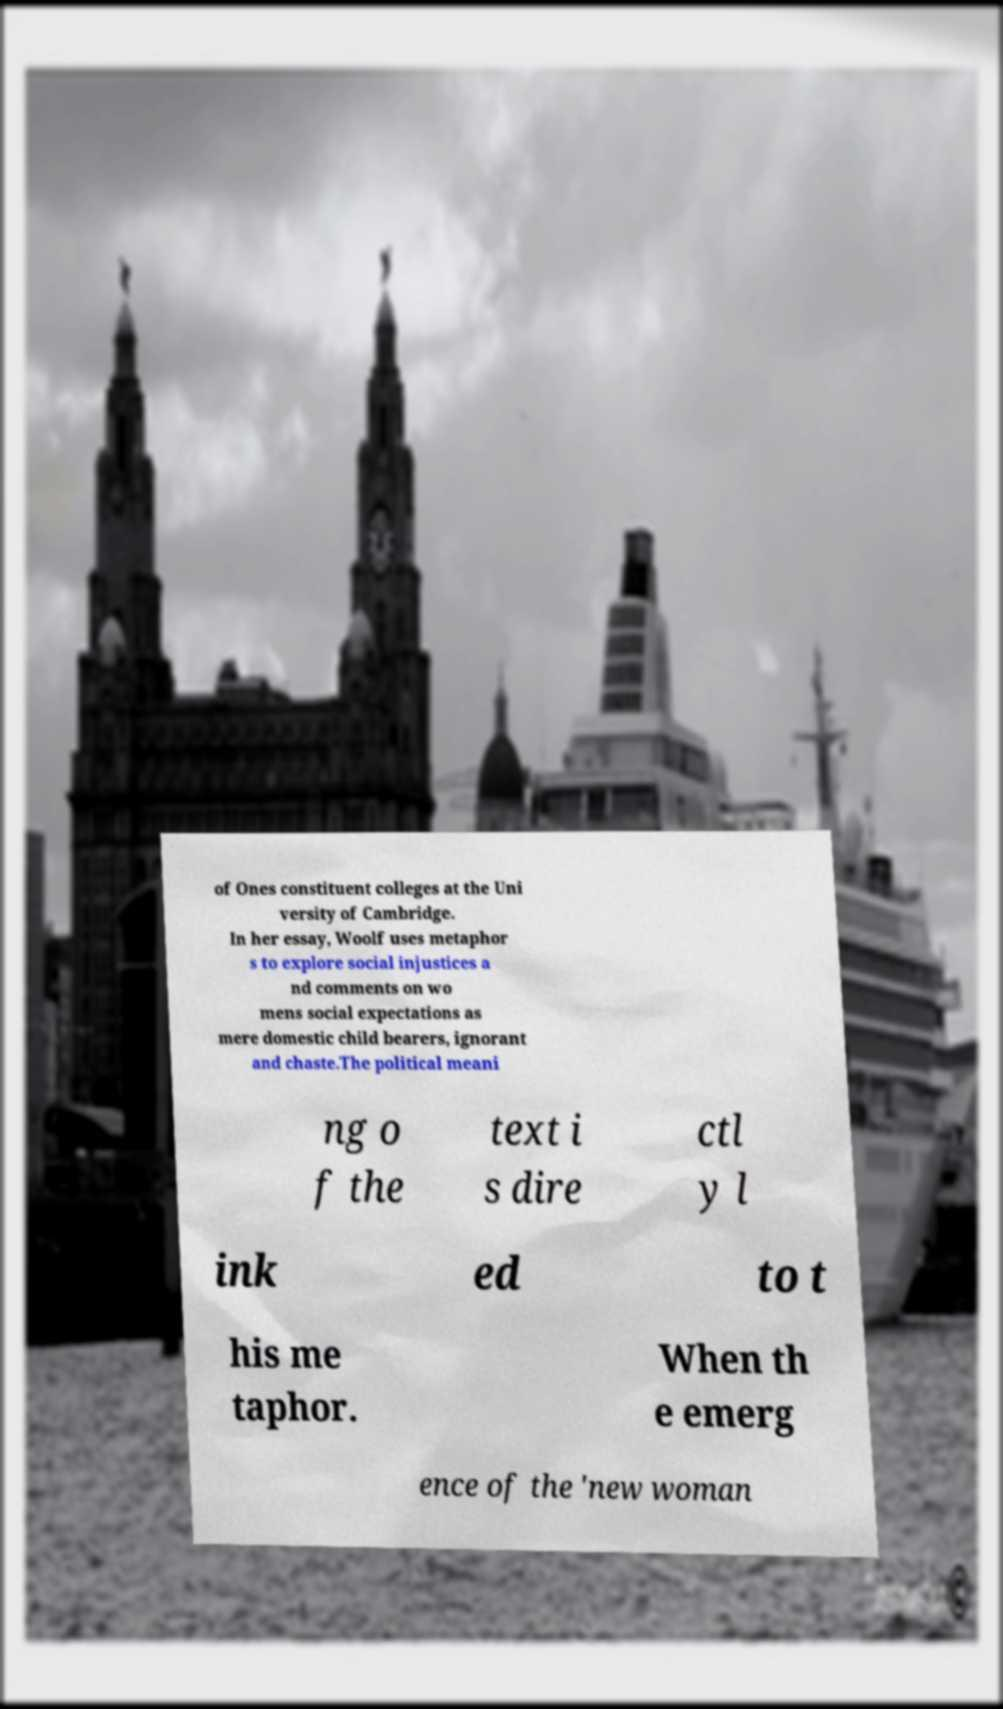Could you extract and type out the text from this image? of Ones constituent colleges at the Uni versity of Cambridge. In her essay, Woolf uses metaphor s to explore social injustices a nd comments on wo mens social expectations as mere domestic child bearers, ignorant and chaste.The political meani ng o f the text i s dire ctl y l ink ed to t his me taphor. When th e emerg ence of the 'new woman 